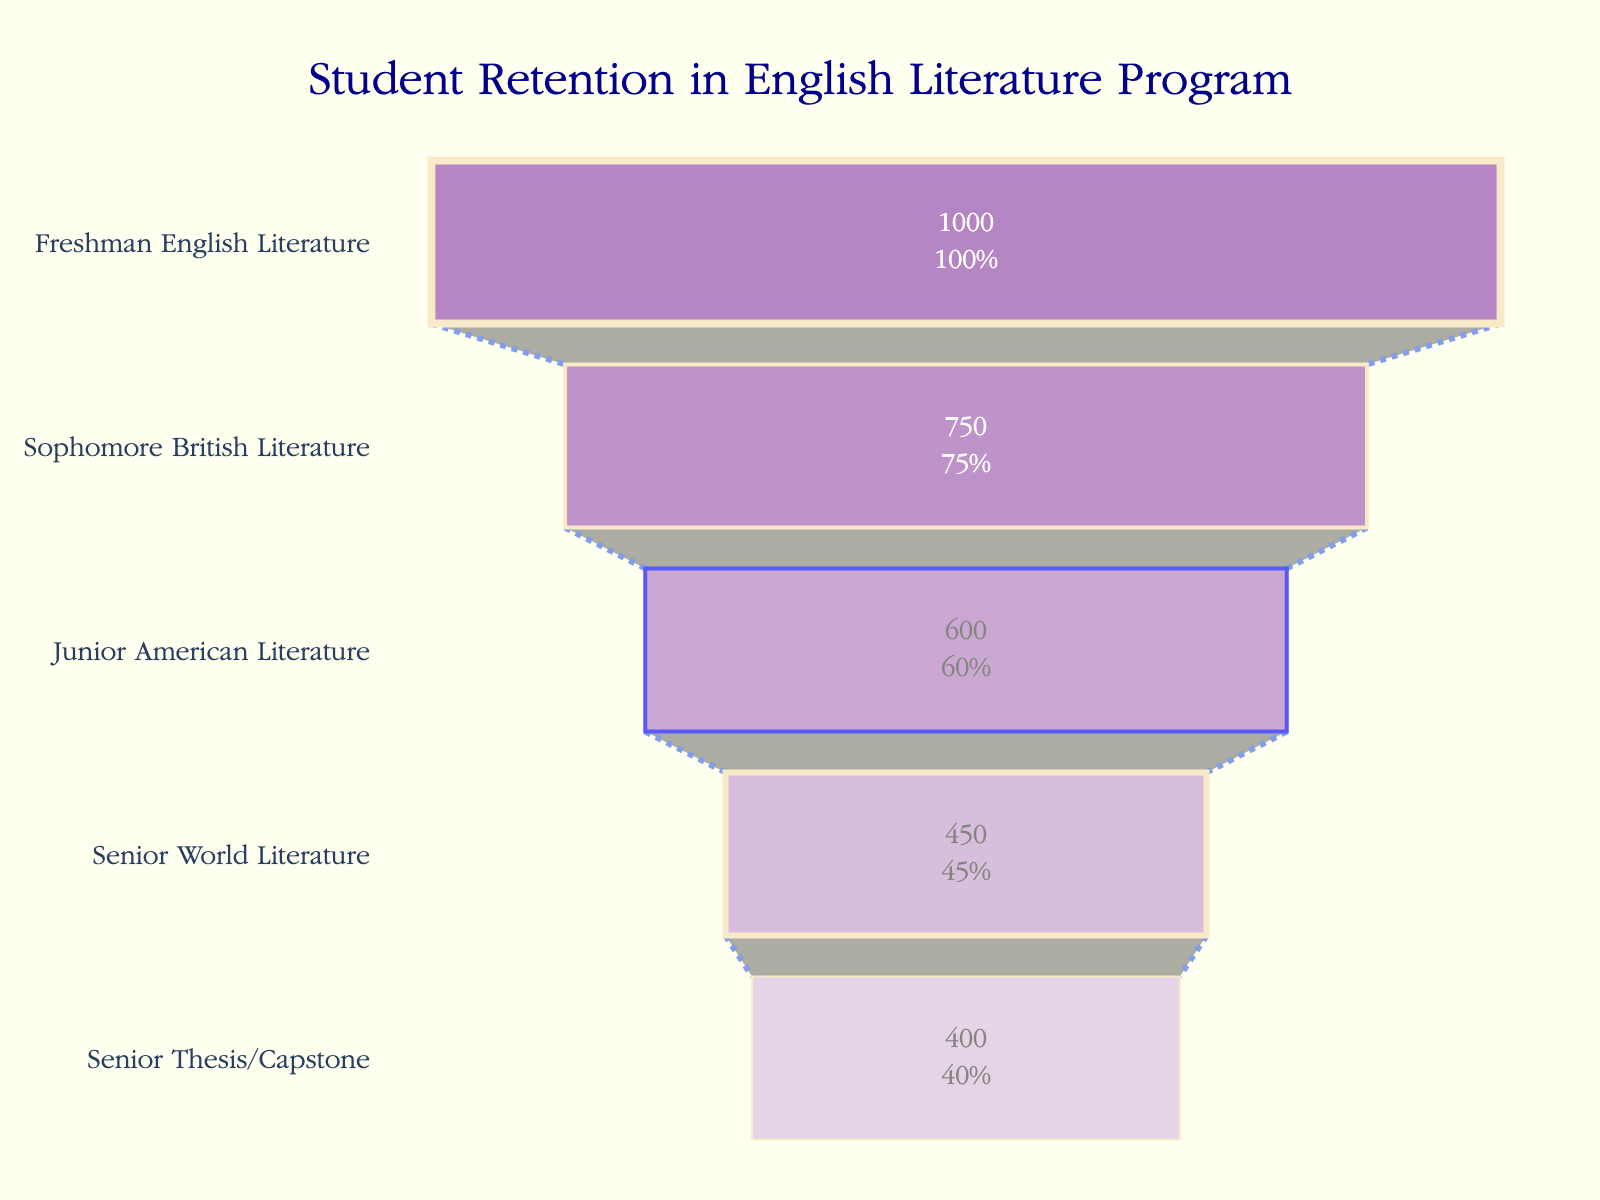What is the title of the figure? The title of the figure is displayed at the top and is typically in larger font. In this case, the title reads "Student Retention in English Literature Program".
Answer: Student Retention in English Literature Program How many stages are presented in the funnel chart? The funnel chart comprises stages or levels, each representing a different academic year or milestone. By counting the levels, you can see there are five stages.
Answer: Five Which stage has the highest number of students? The funnel chart shows the number of students at each stage. By looking at the initial or topmost stage (Freshman English Literature), we see that it has the highest number of students at 1000.
Answer: Freshman English Literature What percentage of students are retained from Freshman English Literature to Sophomore British Literature? The freshman stage starts with 1000 students. The sophomore stage has 750 students. The retention percentage is calculated as (750/1000) * 100%. Performing this calculation gives (750 / 1000) * 100% = 75%.
Answer: 75% What is the difference in the number of students between Junior American Literature and Senior World Literature stages? By looking at the numbers for these stages, Junior American Literature has 600 students and Senior World Literature has 450 students. The difference is calculated as 600 - 450.
Answer: 150 What is the retention rate from Junior American Literature to Senior Thesis/Capstone? The Junior American Literature stage has 600 students, while the Senior Thesis/Capstone stage has 400 students. The retention rate is calculated as (400/600) * 100%. Performing this calculation gives (400 / 600) * 100% = 66.67%.
Answer: 66.67% Which stage shows the smallest decline in student numbers from the previous stage? By examining each transition, the smallest decline must be calculated. Sophomore British Literature to Junior American Literature shows a decline of 750 - 600 = 150, which is smaller than the other declines.
Answer: Sophomore British Literature to Junior American Literature How many students are lost between Freshman English Literature and Senior Thesis/Capstone? This is calculated by subtracting the number of students in the Senior Thesis/Capstone stage from the Freshman English Literature stage: 1000 - 400.
Answer: 600 What is the average number of students from Freshman to Senior World Literature? We add the number of students across these stages and then divide by the number of stages: (1000 + 750 + 600 + 450) / 4. Performing this calculation gives (2800 / 4) = 700.
Answer: 700 What is the main trend depicted in this funnel chart? The chart shows a decreasing trend in the number of students as they progress through the stages from Freshman through to Senior year and to the Thesis/Capstone stage. This indicates a dropout or attrition rate in the program.
Answer: Decreasing students trend 